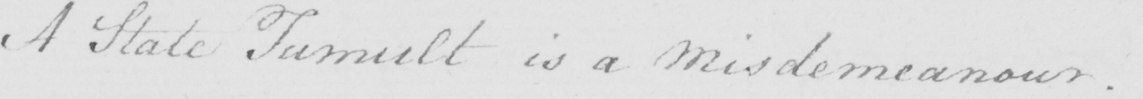What text is written in this handwritten line? A State Tumult is a Misdemeanour. 